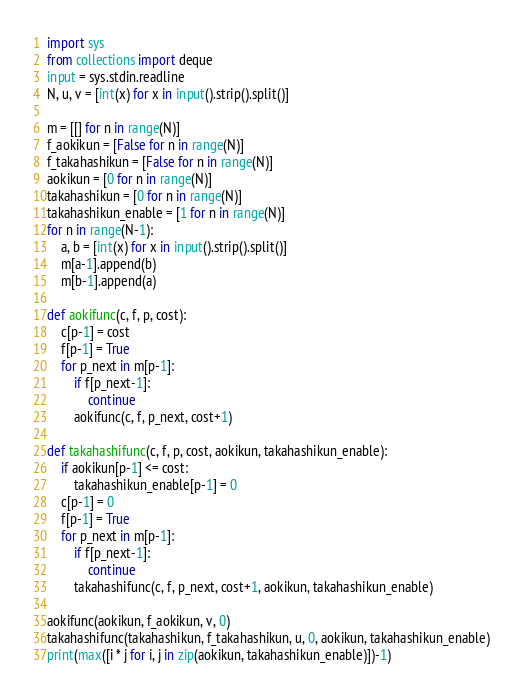<code> <loc_0><loc_0><loc_500><loc_500><_Python_>import sys
from collections import deque
input = sys.stdin.readline
N, u, v = [int(x) for x in input().strip().split()]

m = [[] for n in range(N)]
f_aokikun = [False for n in range(N)]
f_takahashikun = [False for n in range(N)]
aokikun = [0 for n in range(N)]
takahashikun = [0 for n in range(N)]
takahashikun_enable = [1 for n in range(N)]
for n in range(N-1):
    a, b = [int(x) for x in input().strip().split()]
    m[a-1].append(b)
    m[b-1].append(a)

def aokifunc(c, f, p, cost):
    c[p-1] = cost
    f[p-1] = True
    for p_next in m[p-1]:
        if f[p_next-1]:
            continue
        aokifunc(c, f, p_next, cost+1)

def takahashifunc(c, f, p, cost, aokikun, takahashikun_enable):
    if aokikun[p-1] <= cost:
        takahashikun_enable[p-1] = 0
    c[p-1] = 0
    f[p-1] = True
    for p_next in m[p-1]:
        if f[p_next-1]:
            continue
        takahashifunc(c, f, p_next, cost+1, aokikun, takahashikun_enable)

aokifunc(aokikun, f_aokikun, v, 0)
takahashifunc(takahashikun, f_takahashikun, u, 0, aokikun, takahashikun_enable)
print(max([i * j for i, j in zip(aokikun, takahashikun_enable)])-1)</code> 